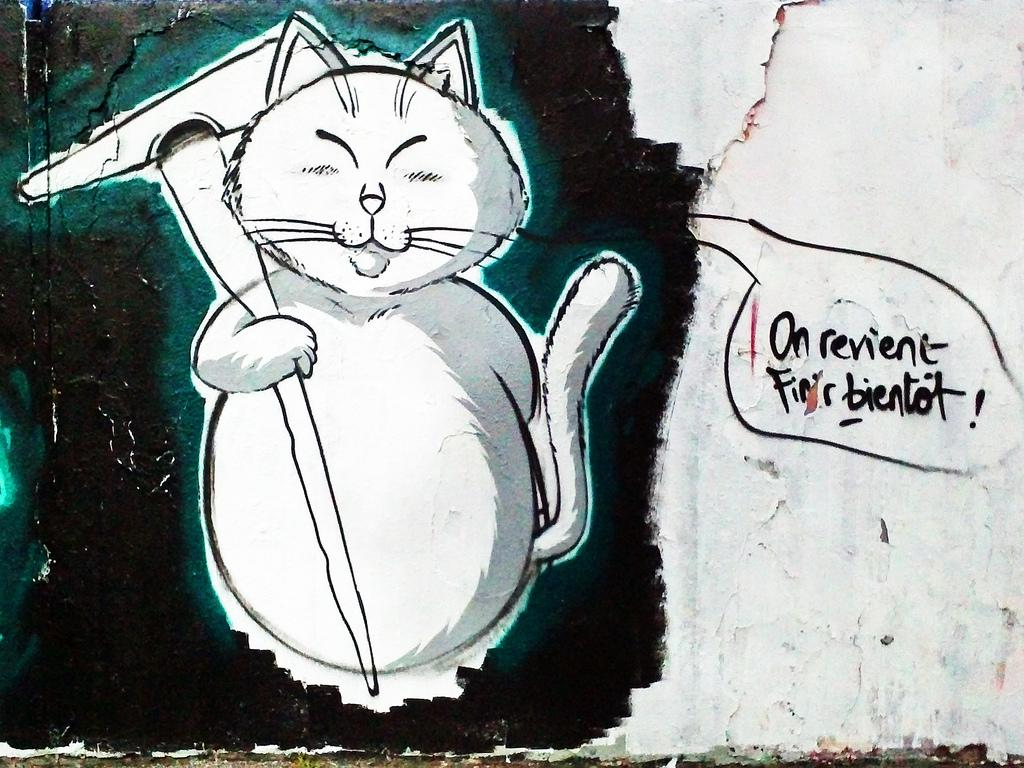What is depicted on the wall in the image? There is a painting on the wall in the image. Can you describe the text on the right side of the wall? There is text on the right side of the wall, but the specific content is not mentioned in the facts. What type of image is on the left side of the wall? There is an image of an animal on the left side of the wall. What is the animal holding in the image? The animal is holding an object in the image. Can you tell me how many knives are being exchanged between the animal and the rock in the image? There is no mention of knives, exchange, or rocks in the image. The animal is holding an object, but its nature is not specified. 